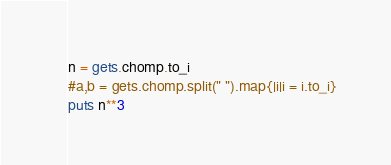<code> <loc_0><loc_0><loc_500><loc_500><_Ruby_>n = gets.chomp.to_i
#a,b = gets.chomp.split(" ").map{|i|i = i.to_i}
puts n**3</code> 